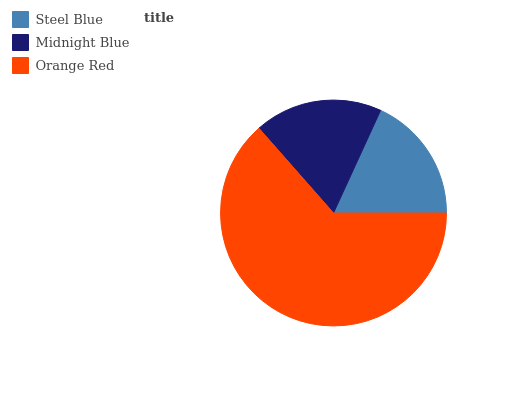Is Steel Blue the minimum?
Answer yes or no. Yes. Is Orange Red the maximum?
Answer yes or no. Yes. Is Midnight Blue the minimum?
Answer yes or no. No. Is Midnight Blue the maximum?
Answer yes or no. No. Is Midnight Blue greater than Steel Blue?
Answer yes or no. Yes. Is Steel Blue less than Midnight Blue?
Answer yes or no. Yes. Is Steel Blue greater than Midnight Blue?
Answer yes or no. No. Is Midnight Blue less than Steel Blue?
Answer yes or no. No. Is Midnight Blue the high median?
Answer yes or no. Yes. Is Midnight Blue the low median?
Answer yes or no. Yes. Is Steel Blue the high median?
Answer yes or no. No. Is Steel Blue the low median?
Answer yes or no. No. 